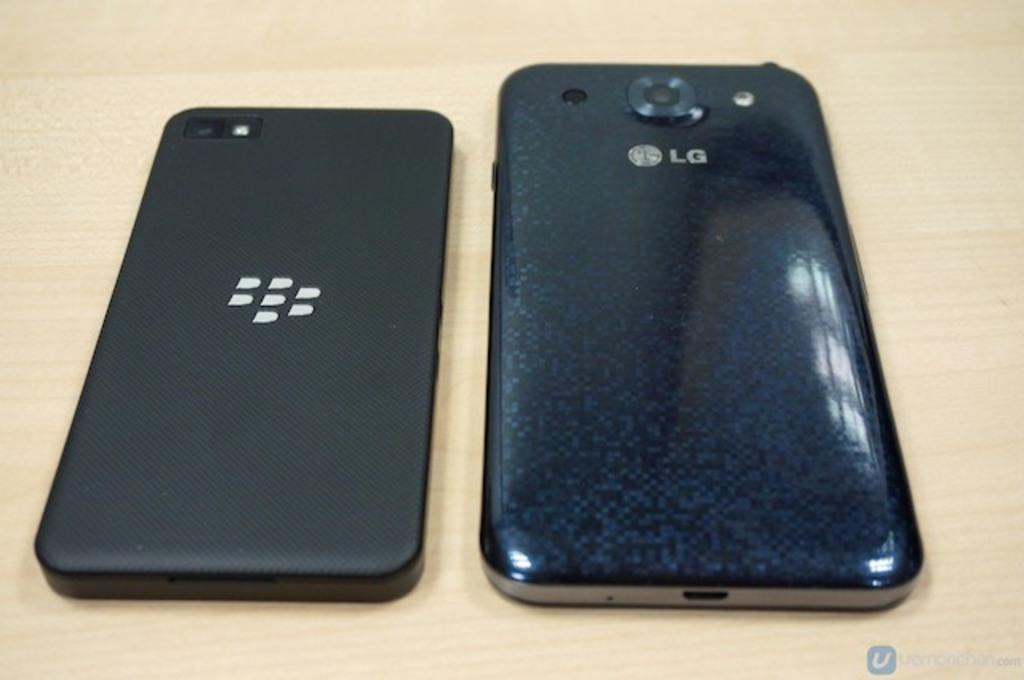<image>
Present a compact description of the photo's key features. the backs of two black cell phones with one reading LG 